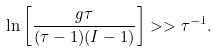<formula> <loc_0><loc_0><loc_500><loc_500>\ln \left [ \frac { g \tau } { ( \tau - 1 ) ( I - 1 ) } \right ] > > \tau ^ { - 1 } .</formula> 